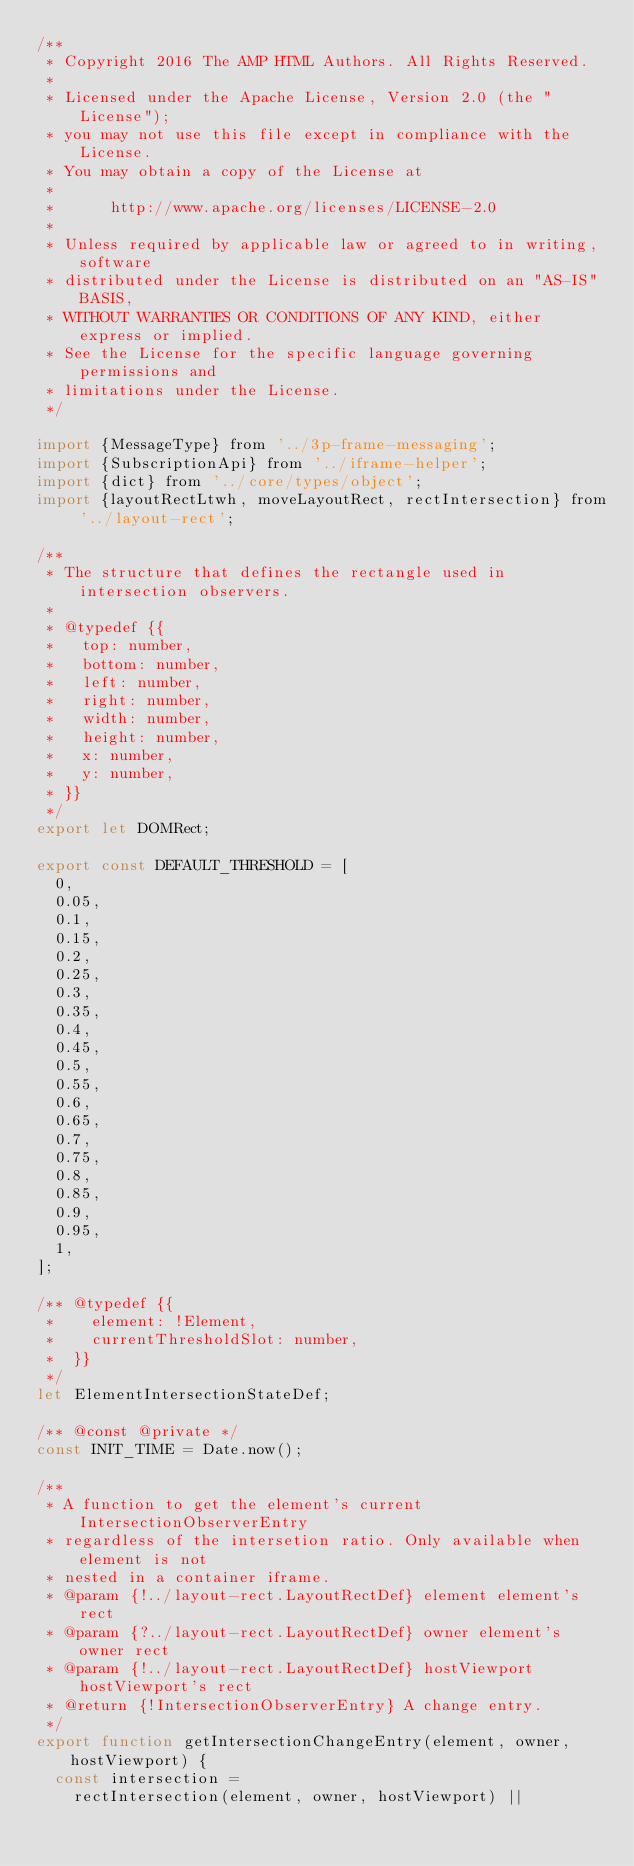<code> <loc_0><loc_0><loc_500><loc_500><_JavaScript_>/**
 * Copyright 2016 The AMP HTML Authors. All Rights Reserved.
 *
 * Licensed under the Apache License, Version 2.0 (the "License");
 * you may not use this file except in compliance with the License.
 * You may obtain a copy of the License at
 *
 *      http://www.apache.org/licenses/LICENSE-2.0
 *
 * Unless required by applicable law or agreed to in writing, software
 * distributed under the License is distributed on an "AS-IS" BASIS,
 * WITHOUT WARRANTIES OR CONDITIONS OF ANY KIND, either express or implied.
 * See the License for the specific language governing permissions and
 * limitations under the License.
 */

import {MessageType} from '../3p-frame-messaging';
import {SubscriptionApi} from '../iframe-helper';
import {dict} from '../core/types/object';
import {layoutRectLtwh, moveLayoutRect, rectIntersection} from '../layout-rect';

/**
 * The structure that defines the rectangle used in intersection observers.
 *
 * @typedef {{
 *   top: number,
 *   bottom: number,
 *   left: number,
 *   right: number,
 *   width: number,
 *   height: number,
 *   x: number,
 *   y: number,
 * }}
 */
export let DOMRect;

export const DEFAULT_THRESHOLD = [
  0,
  0.05,
  0.1,
  0.15,
  0.2,
  0.25,
  0.3,
  0.35,
  0.4,
  0.45,
  0.5,
  0.55,
  0.6,
  0.65,
  0.7,
  0.75,
  0.8,
  0.85,
  0.9,
  0.95,
  1,
];

/** @typedef {{
 *    element: !Element,
 *    currentThresholdSlot: number,
 *  }}
 */
let ElementIntersectionStateDef;

/** @const @private */
const INIT_TIME = Date.now();

/**
 * A function to get the element's current IntersectionObserverEntry
 * regardless of the intersetion ratio. Only available when element is not
 * nested in a container iframe.
 * @param {!../layout-rect.LayoutRectDef} element element's rect
 * @param {?../layout-rect.LayoutRectDef} owner element's owner rect
 * @param {!../layout-rect.LayoutRectDef} hostViewport hostViewport's rect
 * @return {!IntersectionObserverEntry} A change entry.
 */
export function getIntersectionChangeEntry(element, owner, hostViewport) {
  const intersection =
    rectIntersection(element, owner, hostViewport) ||</code> 